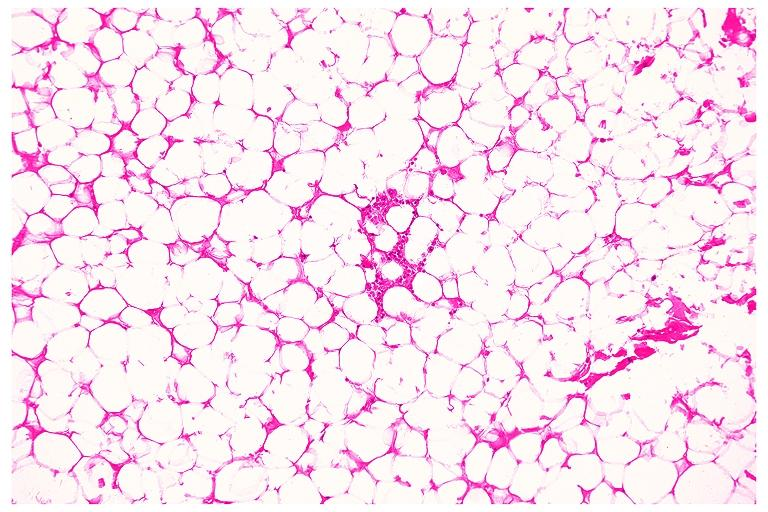does this image show lipoma?
Answer the question using a single word or phrase. Yes 